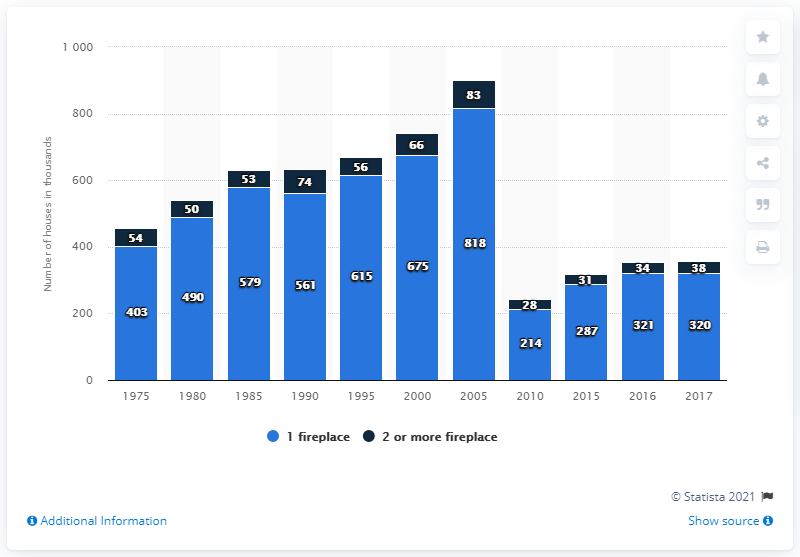Identify some key points in this picture. In the year 1985, there were approximately 526,000 households in the United States that had one or more fireplaces. Additionally, there were approximately 2.5 million households in the United States that had two or more fireplaces. In the year 2017, there were approximately 320 households in the United States that possessed a single fireplace. 